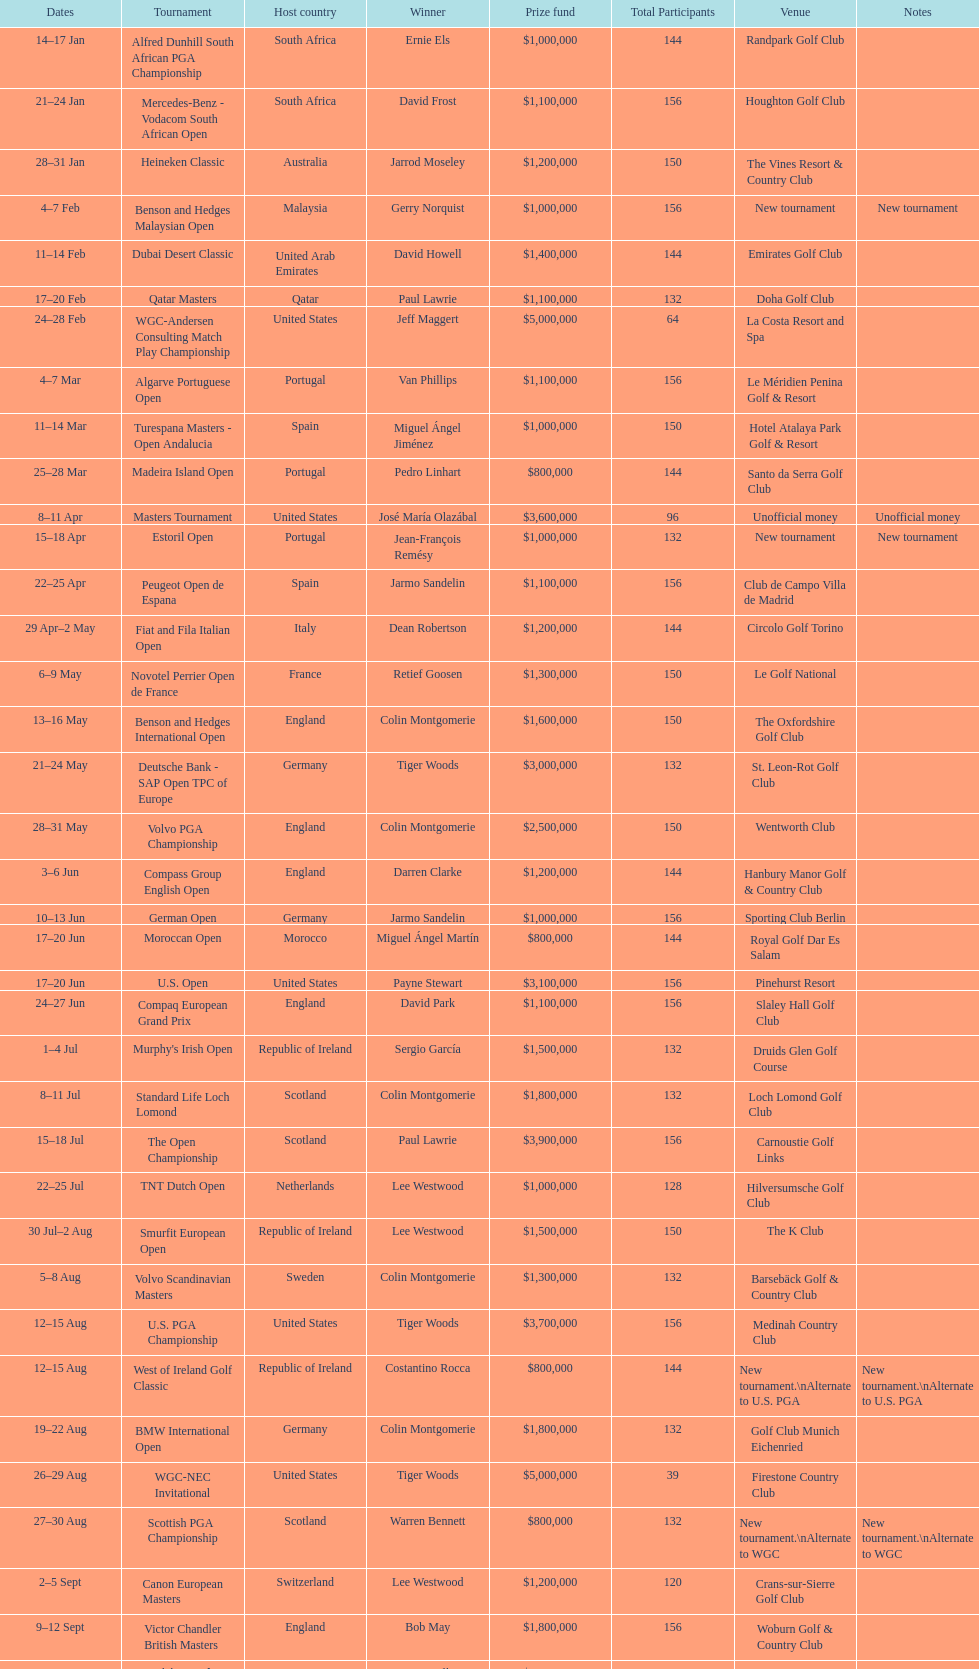Other than qatar masters, name a tournament that was in february. Dubai Desert Classic. 